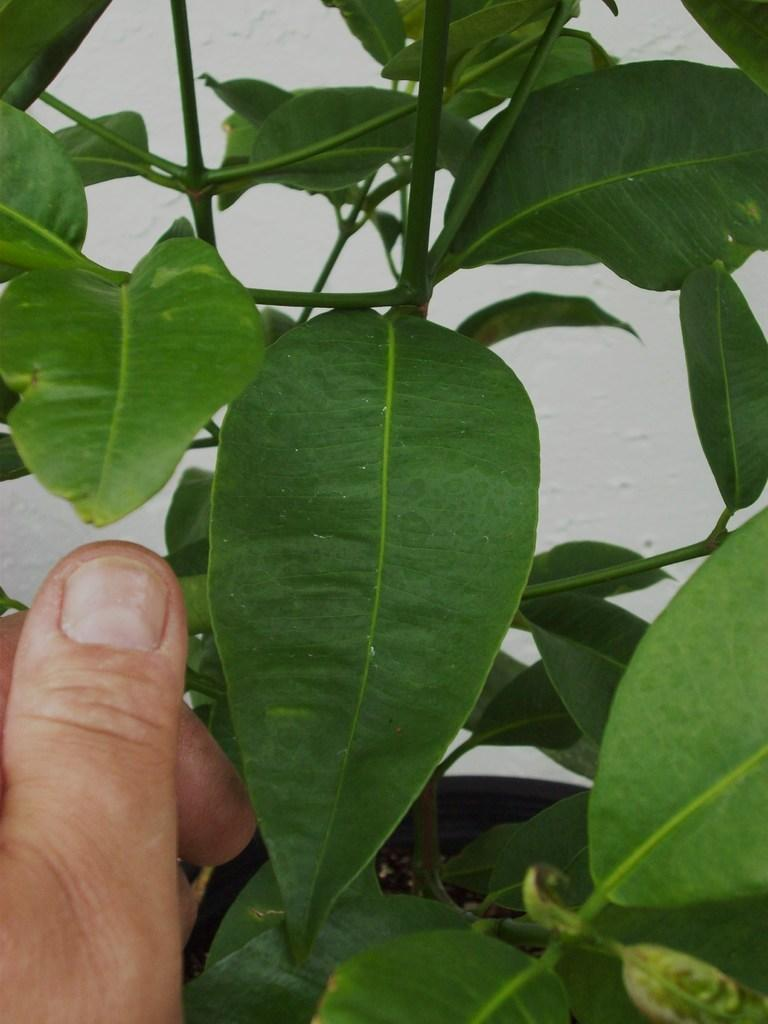What type of living organism is present in the image? There is a plant with leaves in the image. Can you describe the position of the hand in the image? There is a hand at the bottom left of the image. How many frogs are sitting on the leaves of the plant in the image? There are no frogs present on the leaves of the plant in the image. What type of balls can be seen in the image? There are no balls present in the image. 